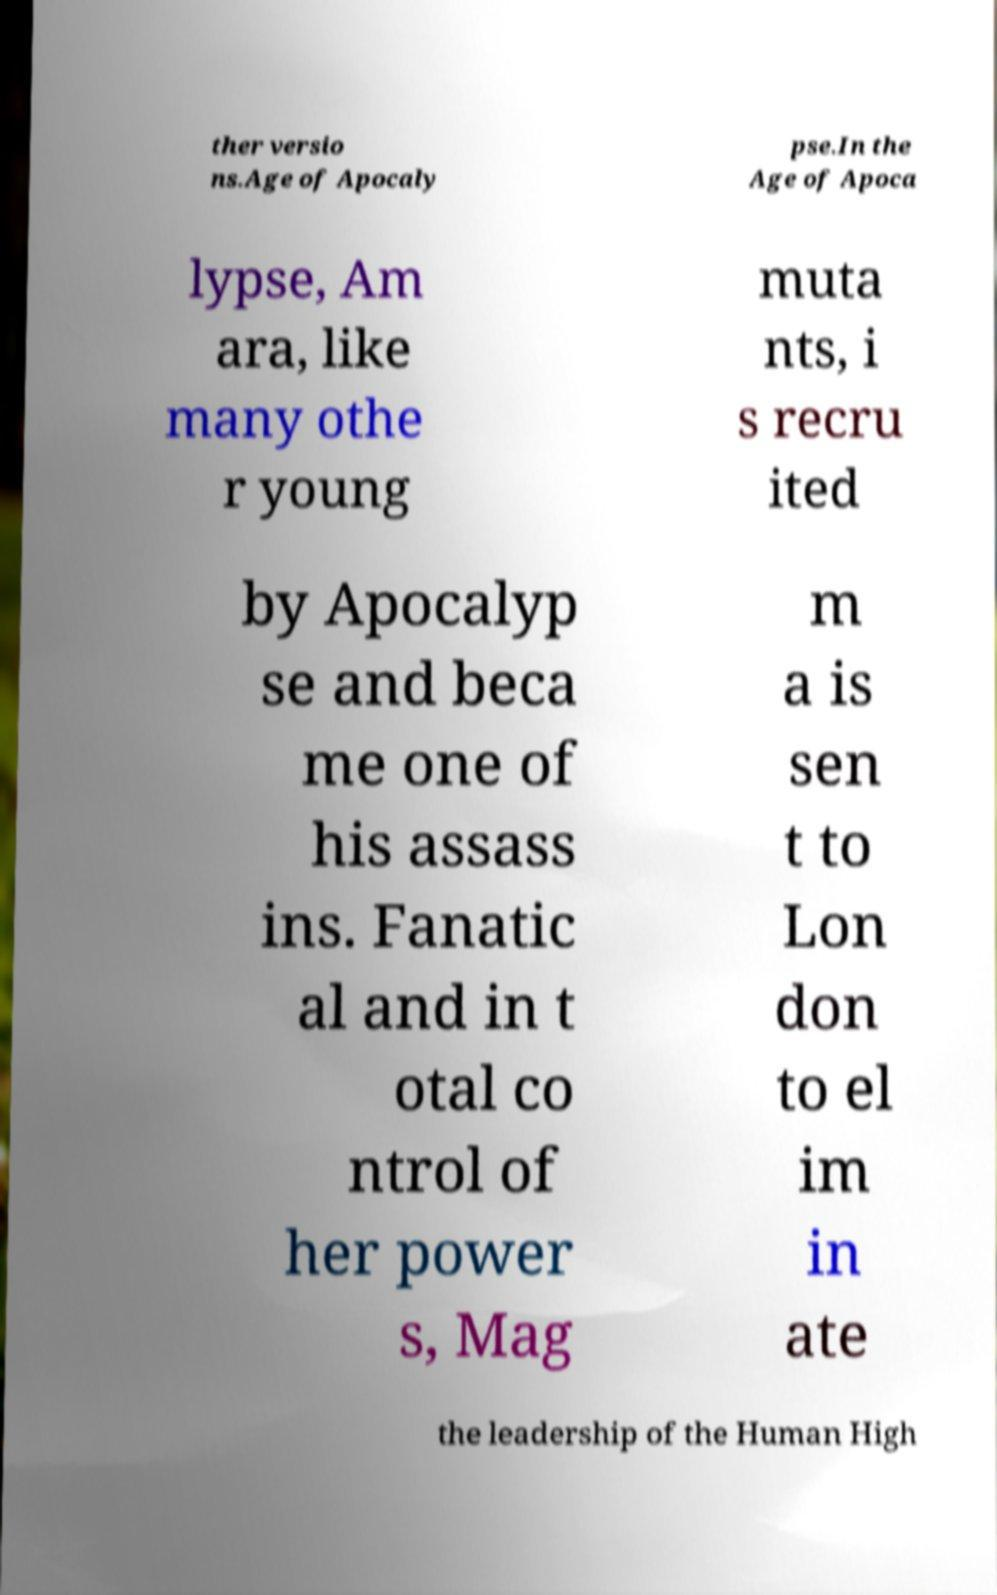Could you assist in decoding the text presented in this image and type it out clearly? ther versio ns.Age of Apocaly pse.In the Age of Apoca lypse, Am ara, like many othe r young muta nts, i s recru ited by Apocalyp se and beca me one of his assass ins. Fanatic al and in t otal co ntrol of her power s, Mag m a is sen t to Lon don to el im in ate the leadership of the Human High 